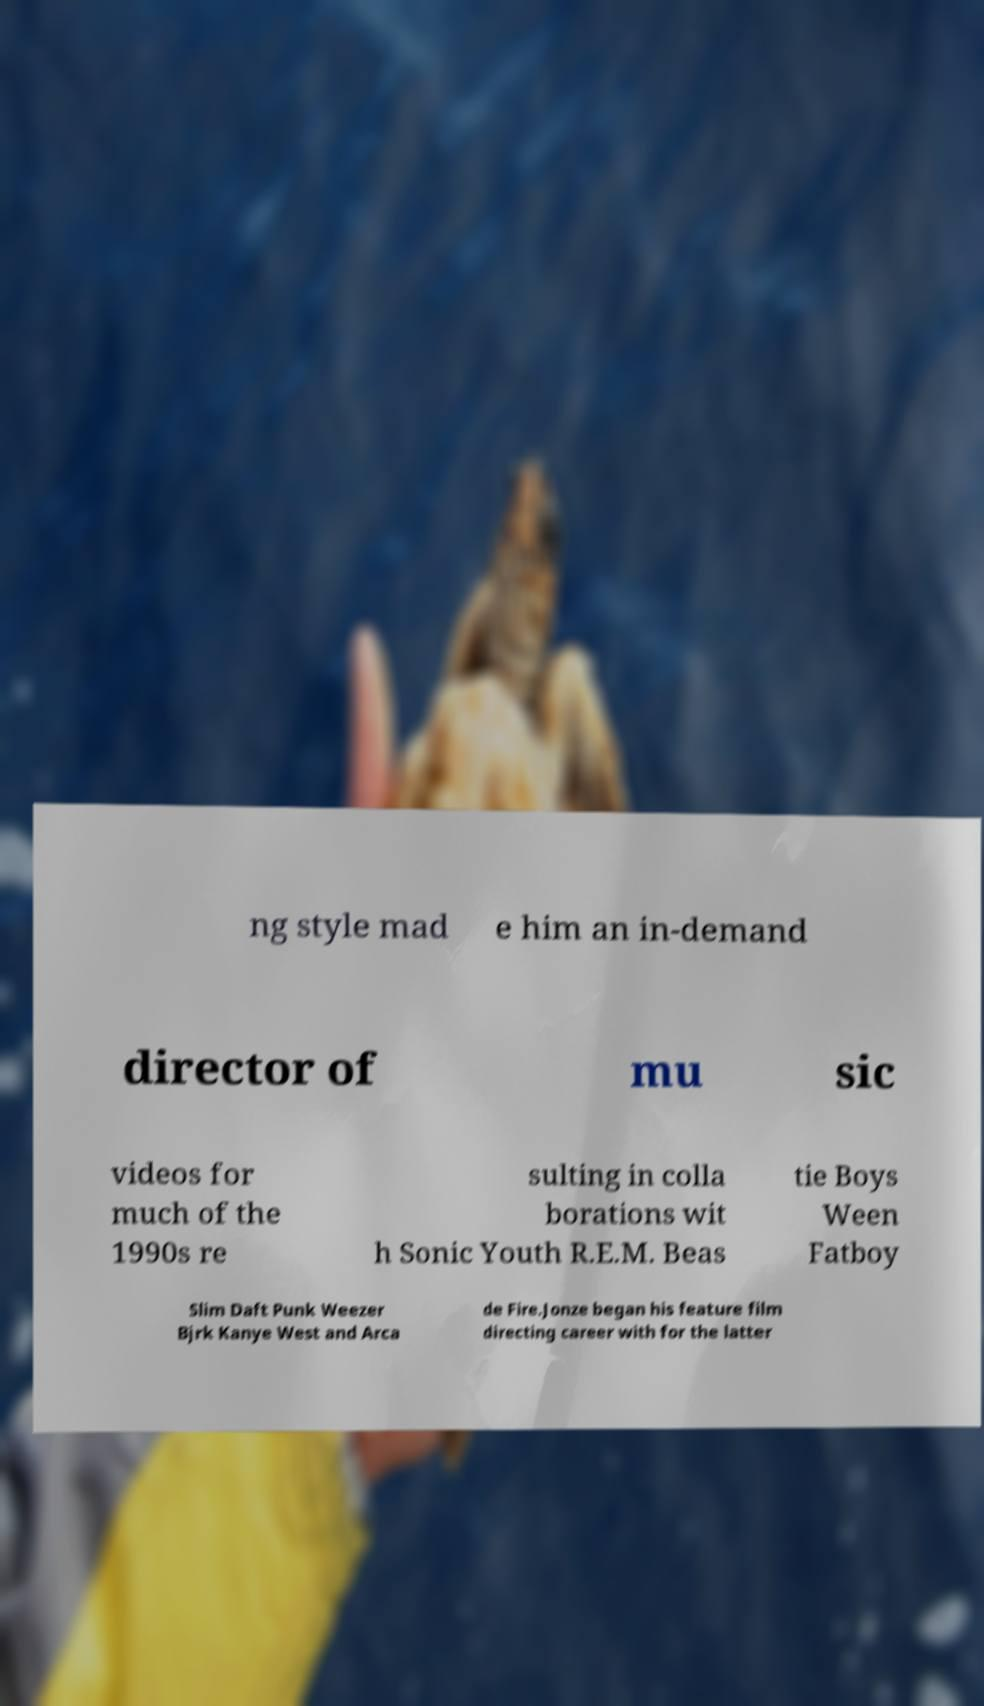Can you read and provide the text displayed in the image?This photo seems to have some interesting text. Can you extract and type it out for me? ng style mad e him an in-demand director of mu sic videos for much of the 1990s re sulting in colla borations wit h Sonic Youth R.E.M. Beas tie Boys Ween Fatboy Slim Daft Punk Weezer Bjrk Kanye West and Arca de Fire.Jonze began his feature film directing career with for the latter 